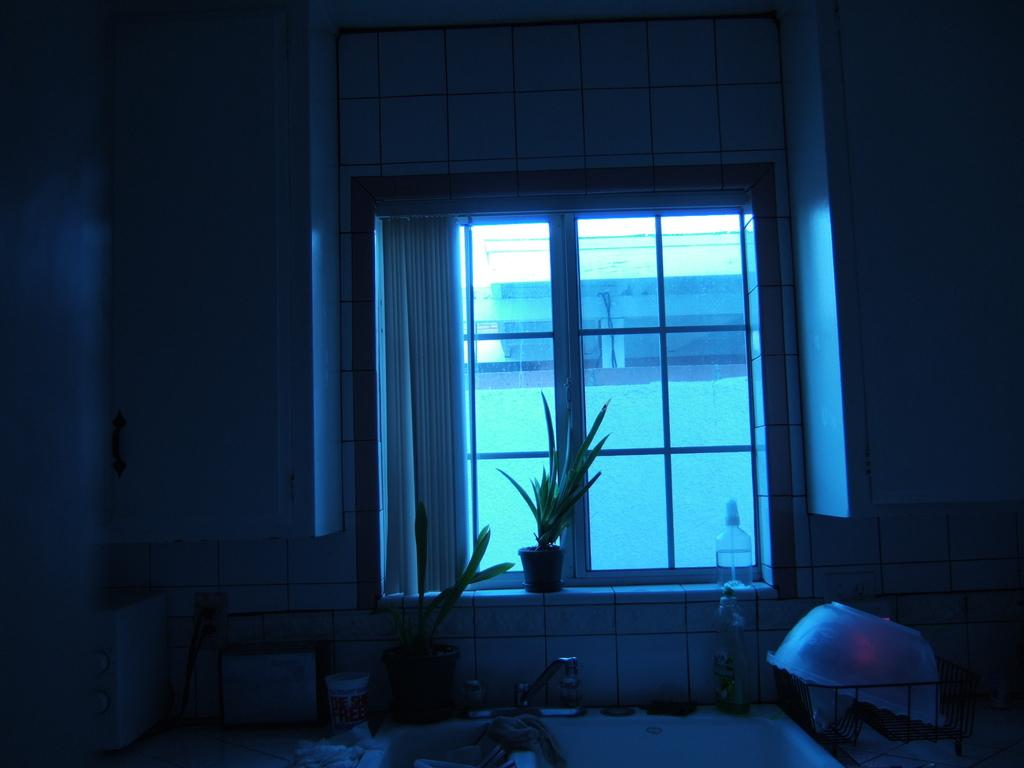What is located in the center of the image? There is a window, a house plant, and a curtain in the center of the image. What can be seen at the bottom of the image? There is a tub and a bathing tub at the bottom of the image. What feature is present in the tub? There is a tap at the bottom of the image. How many streams can be seen flowing through the tub in the image? There are no streams present in the image; it features a tub with a tap. What type of foot is visible in the image? There are no feet visible in the image. 